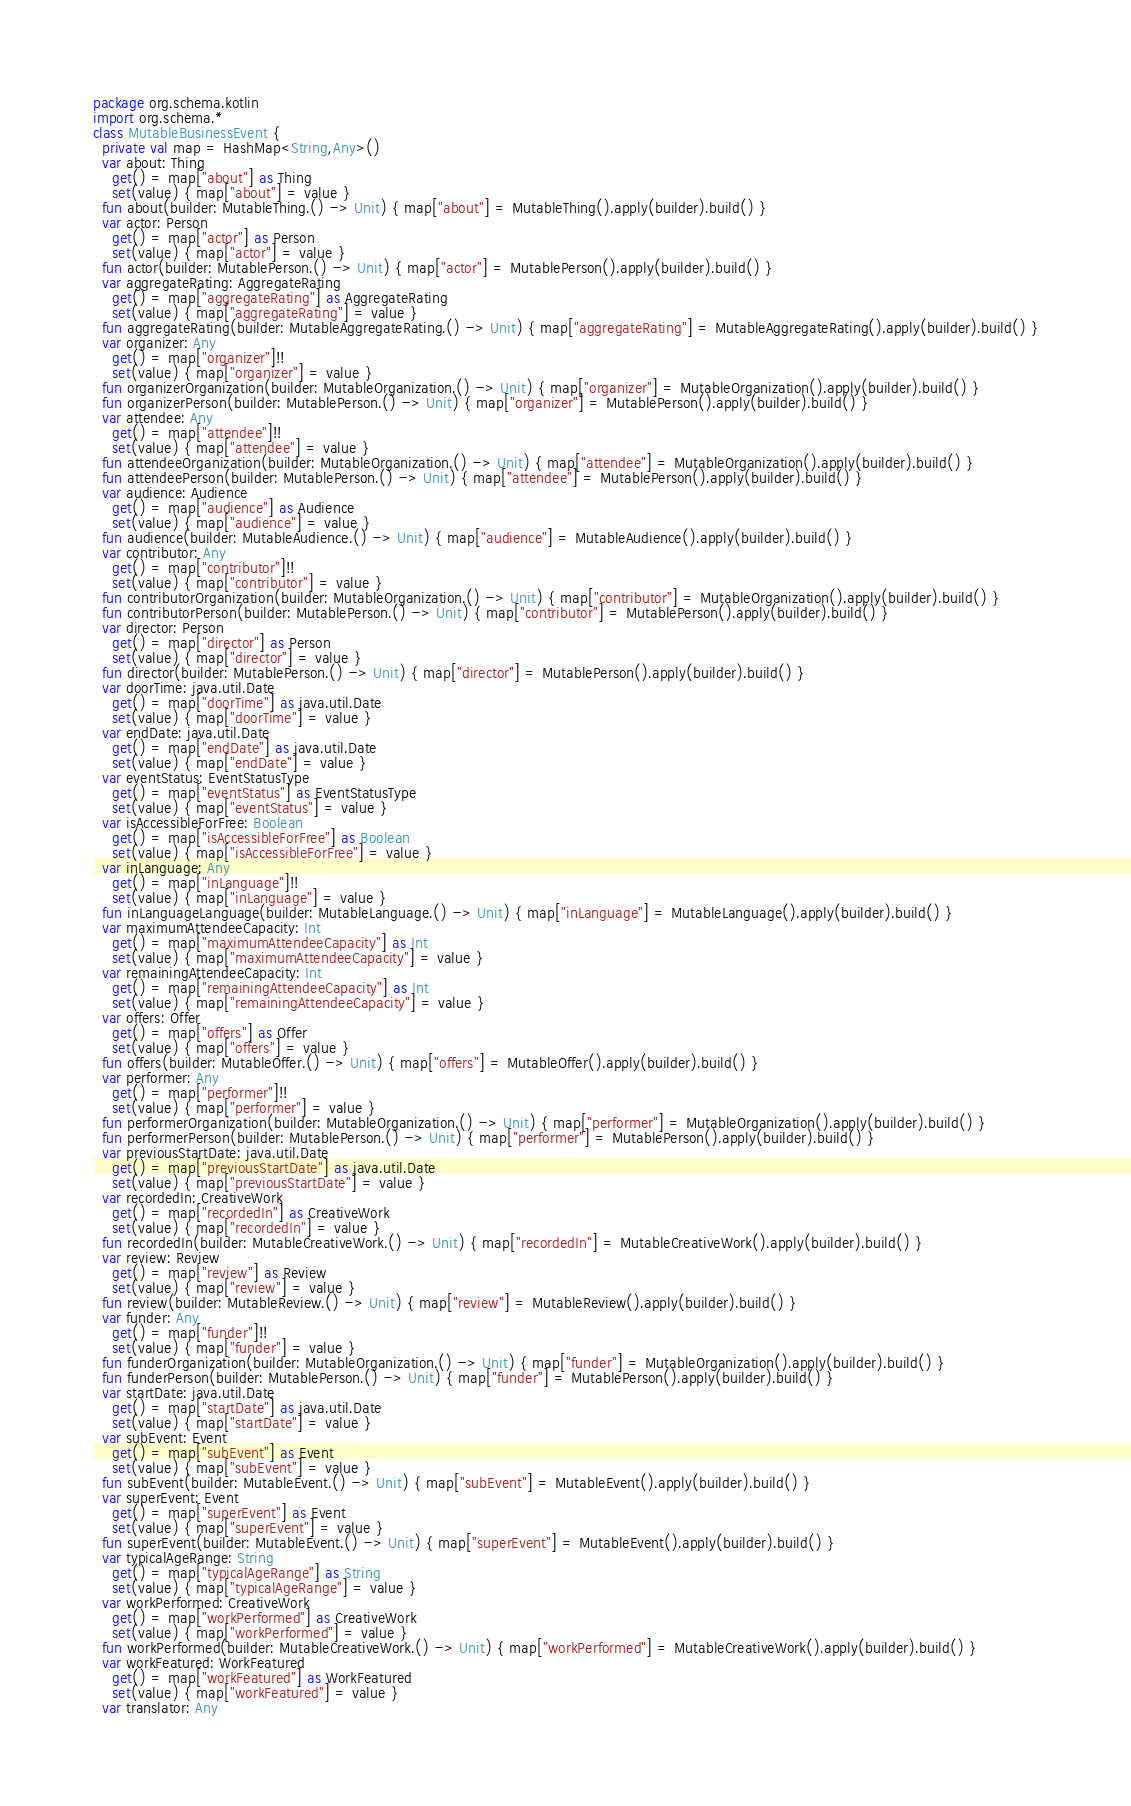Convert code to text. <code><loc_0><loc_0><loc_500><loc_500><_Kotlin_>package org.schema.kotlin
import org.schema.*
class MutableBusinessEvent {
  private val map = HashMap<String,Any>()
  var about: Thing
    get() = map["about"] as Thing
    set(value) { map["about"] = value }
  fun about(builder: MutableThing.() -> Unit) { map["about"] = MutableThing().apply(builder).build() }
  var actor: Person
    get() = map["actor"] as Person
    set(value) { map["actor"] = value }
  fun actor(builder: MutablePerson.() -> Unit) { map["actor"] = MutablePerson().apply(builder).build() }
  var aggregateRating: AggregateRating
    get() = map["aggregateRating"] as AggregateRating
    set(value) { map["aggregateRating"] = value }
  fun aggregateRating(builder: MutableAggregateRating.() -> Unit) { map["aggregateRating"] = MutableAggregateRating().apply(builder).build() }
  var organizer: Any
    get() = map["organizer"]!!
    set(value) { map["organizer"] = value }
  fun organizerOrganization(builder: MutableOrganization.() -> Unit) { map["organizer"] = MutableOrganization().apply(builder).build() }
  fun organizerPerson(builder: MutablePerson.() -> Unit) { map["organizer"] = MutablePerson().apply(builder).build() }
  var attendee: Any
    get() = map["attendee"]!!
    set(value) { map["attendee"] = value }
  fun attendeeOrganization(builder: MutableOrganization.() -> Unit) { map["attendee"] = MutableOrganization().apply(builder).build() }
  fun attendeePerson(builder: MutablePerson.() -> Unit) { map["attendee"] = MutablePerson().apply(builder).build() }
  var audience: Audience
    get() = map["audience"] as Audience
    set(value) { map["audience"] = value }
  fun audience(builder: MutableAudience.() -> Unit) { map["audience"] = MutableAudience().apply(builder).build() }
  var contributor: Any
    get() = map["contributor"]!!
    set(value) { map["contributor"] = value }
  fun contributorOrganization(builder: MutableOrganization.() -> Unit) { map["contributor"] = MutableOrganization().apply(builder).build() }
  fun contributorPerson(builder: MutablePerson.() -> Unit) { map["contributor"] = MutablePerson().apply(builder).build() }
  var director: Person
    get() = map["director"] as Person
    set(value) { map["director"] = value }
  fun director(builder: MutablePerson.() -> Unit) { map["director"] = MutablePerson().apply(builder).build() }
  var doorTime: java.util.Date
    get() = map["doorTime"] as java.util.Date
    set(value) { map["doorTime"] = value }
  var endDate: java.util.Date
    get() = map["endDate"] as java.util.Date
    set(value) { map["endDate"] = value }
  var eventStatus: EventStatusType
    get() = map["eventStatus"] as EventStatusType
    set(value) { map["eventStatus"] = value }
  var isAccessibleForFree: Boolean
    get() = map["isAccessibleForFree"] as Boolean
    set(value) { map["isAccessibleForFree"] = value }
  var inLanguage: Any
    get() = map["inLanguage"]!!
    set(value) { map["inLanguage"] = value }
  fun inLanguageLanguage(builder: MutableLanguage.() -> Unit) { map["inLanguage"] = MutableLanguage().apply(builder).build() }
  var maximumAttendeeCapacity: Int
    get() = map["maximumAttendeeCapacity"] as Int
    set(value) { map["maximumAttendeeCapacity"] = value }
  var remainingAttendeeCapacity: Int
    get() = map["remainingAttendeeCapacity"] as Int
    set(value) { map["remainingAttendeeCapacity"] = value }
  var offers: Offer
    get() = map["offers"] as Offer
    set(value) { map["offers"] = value }
  fun offers(builder: MutableOffer.() -> Unit) { map["offers"] = MutableOffer().apply(builder).build() }
  var performer: Any
    get() = map["performer"]!!
    set(value) { map["performer"] = value }
  fun performerOrganization(builder: MutableOrganization.() -> Unit) { map["performer"] = MutableOrganization().apply(builder).build() }
  fun performerPerson(builder: MutablePerson.() -> Unit) { map["performer"] = MutablePerson().apply(builder).build() }
  var previousStartDate: java.util.Date
    get() = map["previousStartDate"] as java.util.Date
    set(value) { map["previousStartDate"] = value }
  var recordedIn: CreativeWork
    get() = map["recordedIn"] as CreativeWork
    set(value) { map["recordedIn"] = value }
  fun recordedIn(builder: MutableCreativeWork.() -> Unit) { map["recordedIn"] = MutableCreativeWork().apply(builder).build() }
  var review: Review
    get() = map["review"] as Review
    set(value) { map["review"] = value }
  fun review(builder: MutableReview.() -> Unit) { map["review"] = MutableReview().apply(builder).build() }
  var funder: Any
    get() = map["funder"]!!
    set(value) { map["funder"] = value }
  fun funderOrganization(builder: MutableOrganization.() -> Unit) { map["funder"] = MutableOrganization().apply(builder).build() }
  fun funderPerson(builder: MutablePerson.() -> Unit) { map["funder"] = MutablePerson().apply(builder).build() }
  var startDate: java.util.Date
    get() = map["startDate"] as java.util.Date
    set(value) { map["startDate"] = value }
  var subEvent: Event
    get() = map["subEvent"] as Event
    set(value) { map["subEvent"] = value }
  fun subEvent(builder: MutableEvent.() -> Unit) { map["subEvent"] = MutableEvent().apply(builder).build() }
  var superEvent: Event
    get() = map["superEvent"] as Event
    set(value) { map["superEvent"] = value }
  fun superEvent(builder: MutableEvent.() -> Unit) { map["superEvent"] = MutableEvent().apply(builder).build() }
  var typicalAgeRange: String
    get() = map["typicalAgeRange"] as String
    set(value) { map["typicalAgeRange"] = value }
  var workPerformed: CreativeWork
    get() = map["workPerformed"] as CreativeWork
    set(value) { map["workPerformed"] = value }
  fun workPerformed(builder: MutableCreativeWork.() -> Unit) { map["workPerformed"] = MutableCreativeWork().apply(builder).build() }
  var workFeatured: WorkFeatured
    get() = map["workFeatured"] as WorkFeatured
    set(value) { map["workFeatured"] = value }
  var translator: Any</code> 